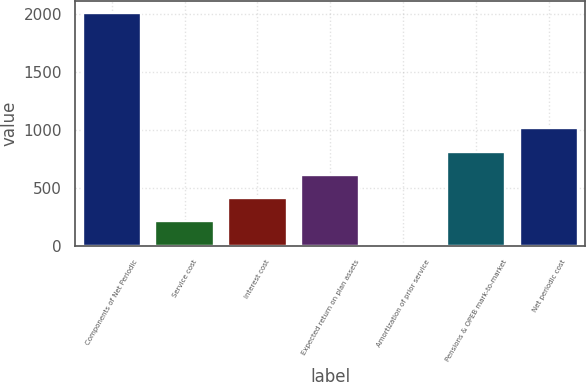Convert chart to OTSL. <chart><loc_0><loc_0><loc_500><loc_500><bar_chart><fcel>Components of Net Periodic<fcel>Service cost<fcel>Interest cost<fcel>Expected return on plan assets<fcel>Amortization of prior service<fcel>Pensions & OPEB mark-to-market<fcel>Net periodic cost<nl><fcel>2011<fcel>213.7<fcel>413.4<fcel>613.1<fcel>14<fcel>812.8<fcel>1012.5<nl></chart> 